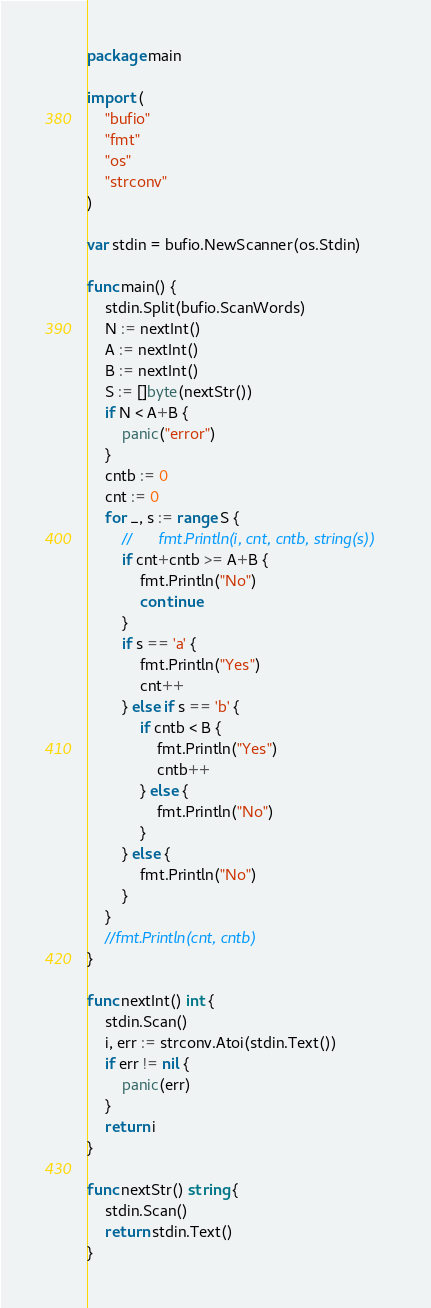<code> <loc_0><loc_0><loc_500><loc_500><_Go_>package main

import (
	"bufio"
	"fmt"
	"os"
	"strconv"
)

var stdin = bufio.NewScanner(os.Stdin)

func main() {
	stdin.Split(bufio.ScanWords)
	N := nextInt()
	A := nextInt()
	B := nextInt()
	S := []byte(nextStr())
	if N < A+B {
		panic("error")
	}
	cntb := 0
	cnt := 0
	for _, s := range S {
		//		fmt.Println(i, cnt, cntb, string(s))
		if cnt+cntb >= A+B {
			fmt.Println("No")
			continue
		}
		if s == 'a' {
			fmt.Println("Yes")
			cnt++
		} else if s == 'b' {
			if cntb < B {
				fmt.Println("Yes")
				cntb++
			} else {
				fmt.Println("No")
			}
		} else {
			fmt.Println("No")
		}
	}
	//fmt.Println(cnt, cntb)
}

func nextInt() int {
	stdin.Scan()
	i, err := strconv.Atoi(stdin.Text())
	if err != nil {
		panic(err)
	}
	return i
}

func nextStr() string {
	stdin.Scan()
	return stdin.Text()
}
</code> 